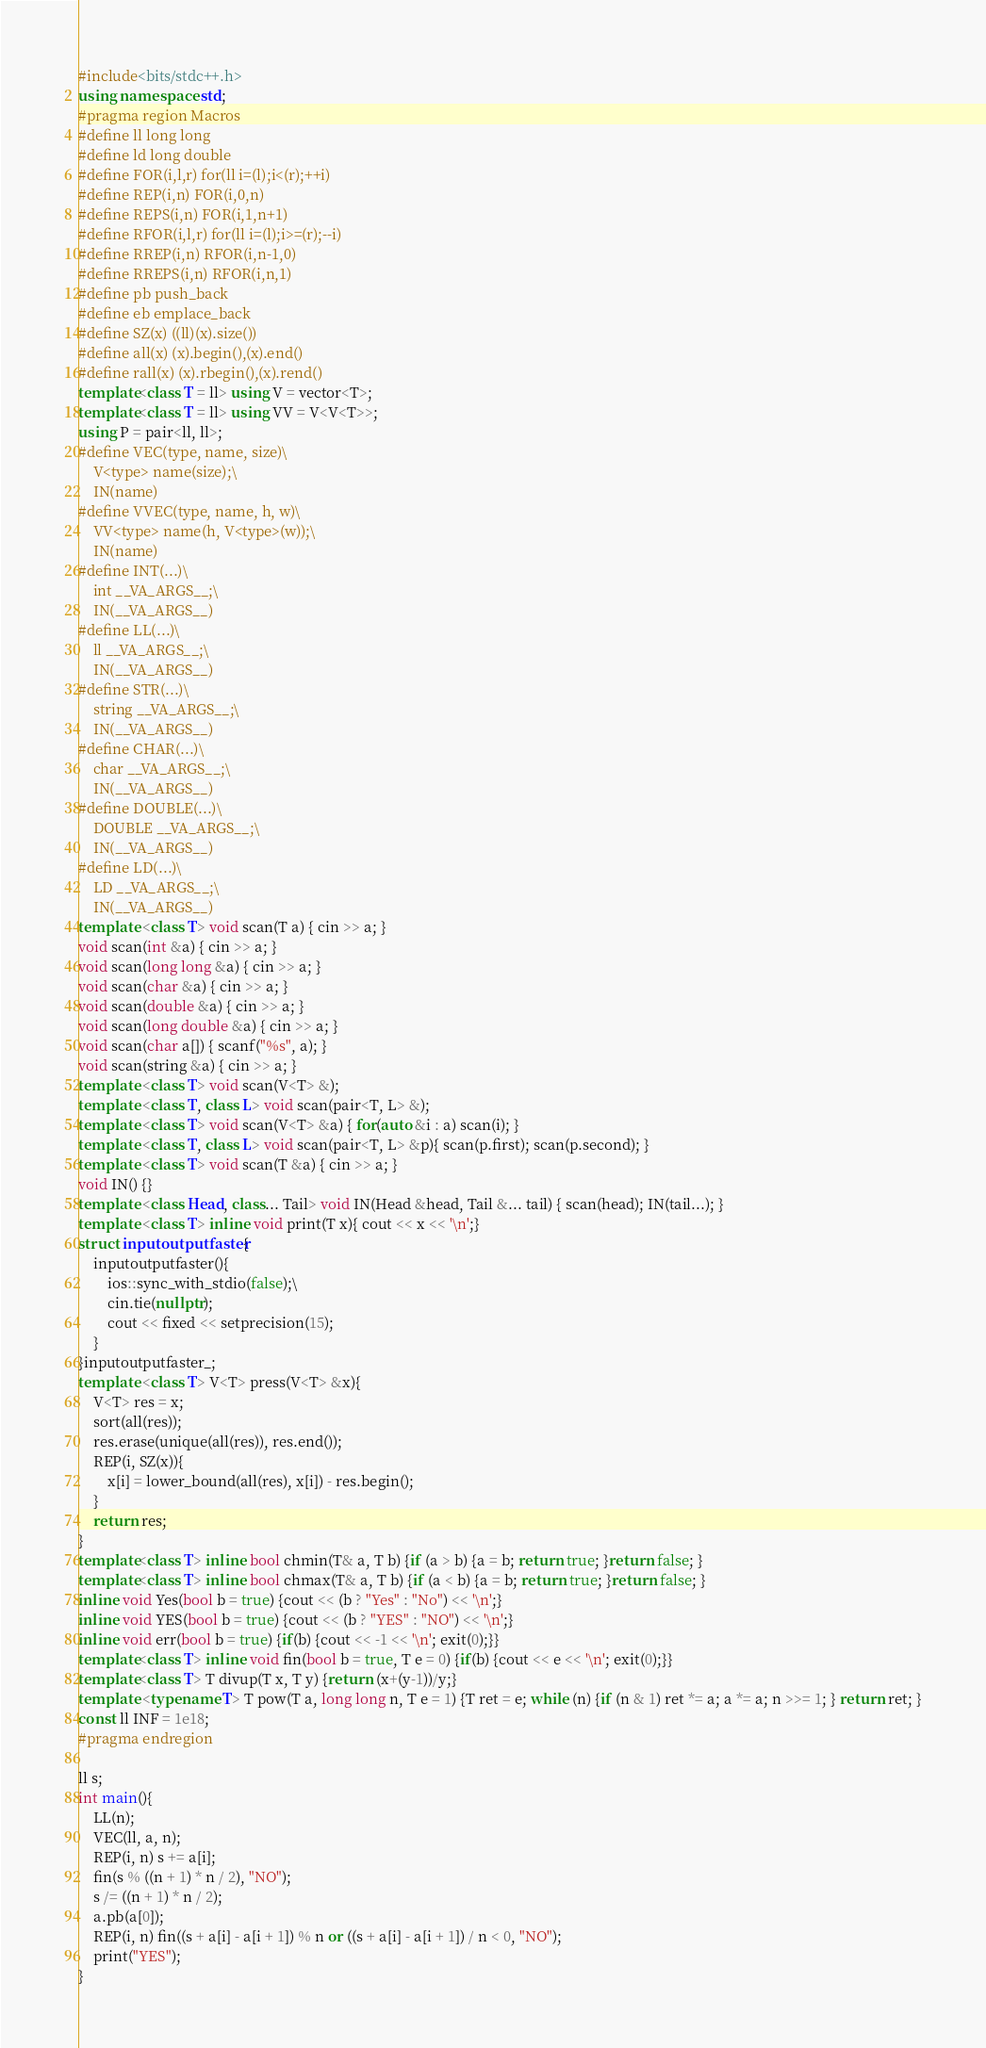Convert code to text. <code><loc_0><loc_0><loc_500><loc_500><_C++_>#include<bits/stdc++.h>
using namespace std;
#pragma region Macros
#define ll long long
#define ld long double
#define FOR(i,l,r) for(ll i=(l);i<(r);++i)
#define REP(i,n) FOR(i,0,n)
#define REPS(i,n) FOR(i,1,n+1)
#define RFOR(i,l,r) for(ll i=(l);i>=(r);--i)
#define RREP(i,n) RFOR(i,n-1,0)
#define RREPS(i,n) RFOR(i,n,1)
#define pb push_back
#define eb emplace_back
#define SZ(x) ((ll)(x).size())
#define all(x) (x).begin(),(x).end()
#define rall(x) (x).rbegin(),(x).rend()
template<class T = ll> using V = vector<T>;
template<class T = ll> using VV = V<V<T>>;
using P = pair<ll, ll>;
#define VEC(type, name, size)\
    V<type> name(size);\
    IN(name)
#define VVEC(type, name, h, w)\
    VV<type> name(h, V<type>(w));\
    IN(name)
#define INT(...)\
    int __VA_ARGS__;\
    IN(__VA_ARGS__)
#define LL(...)\
    ll __VA_ARGS__;\
    IN(__VA_ARGS__)
#define STR(...)\
    string __VA_ARGS__;\
    IN(__VA_ARGS__)
#define CHAR(...)\
    char __VA_ARGS__;\
    IN(__VA_ARGS__)
#define DOUBLE(...)\
    DOUBLE __VA_ARGS__;\
    IN(__VA_ARGS__)
#define LD(...)\
    LD __VA_ARGS__;\
    IN(__VA_ARGS__)
template <class T> void scan(T a) { cin >> a; }
void scan(int &a) { cin >> a; }
void scan(long long &a) { cin >> a; }
void scan(char &a) { cin >> a; }
void scan(double &a) { cin >> a; }
void scan(long double &a) { cin >> a; }
void scan(char a[]) { scanf("%s", a); }
void scan(string &a) { cin >> a; }
template <class T> void scan(V<T> &);
template <class T, class L> void scan(pair<T, L> &);
template <class T> void scan(V<T> &a) { for(auto &i : a) scan(i); }
template <class T, class L> void scan(pair<T, L> &p){ scan(p.first); scan(p.second); }
template <class T> void scan(T &a) { cin >> a; }
void IN() {}
template <class Head, class... Tail> void IN(Head &head, Tail &... tail) { scan(head); IN(tail...); }
template <class T> inline void print(T x){ cout << x << '\n';}
struct inputoutputfaster{
    inputoutputfaster(){
        ios::sync_with_stdio(false);\
        cin.tie(nullptr);
        cout << fixed << setprecision(15);
    }
}inputoutputfaster_;
template <class T> V<T> press(V<T> &x){ 
    V<T> res = x;
    sort(all(res));
    res.erase(unique(all(res)), res.end());
    REP(i, SZ(x)){
        x[i] = lower_bound(all(res), x[i]) - res.begin();
    }
    return res;
}
template<class T> inline bool chmin(T& a, T b) {if (a > b) {a = b; return true; }return false; }
template<class T> inline bool chmax(T& a, T b) {if (a < b) {a = b; return true; }return false; }
inline void Yes(bool b = true) {cout << (b ? "Yes" : "No") << '\n';}
inline void YES(bool b = true) {cout << (b ? "YES" : "NO") << '\n';}
inline void err(bool b = true) {if(b) {cout << -1 << '\n'; exit(0);}}
template<class T> inline void fin(bool b = true, T e = 0) {if(b) {cout << e << '\n'; exit(0);}}
template<class T> T divup(T x, T y) {return (x+(y-1))/y;}
template <typename T> T pow(T a, long long n, T e = 1) {T ret = e; while (n) {if (n & 1) ret *= a; a *= a; n >>= 1; } return ret; }
const ll INF = 1e18;
#pragma endregion

ll s;
int main(){
    LL(n);
    VEC(ll, a, n);
    REP(i, n) s += a[i];
    fin(s % ((n + 1) * n / 2), "NO");
    s /= ((n + 1) * n / 2);
    a.pb(a[0]);
    REP(i, n) fin((s + a[i] - a[i + 1]) % n or ((s + a[i] - a[i + 1]) / n < 0, "NO");
    print("YES");
}</code> 